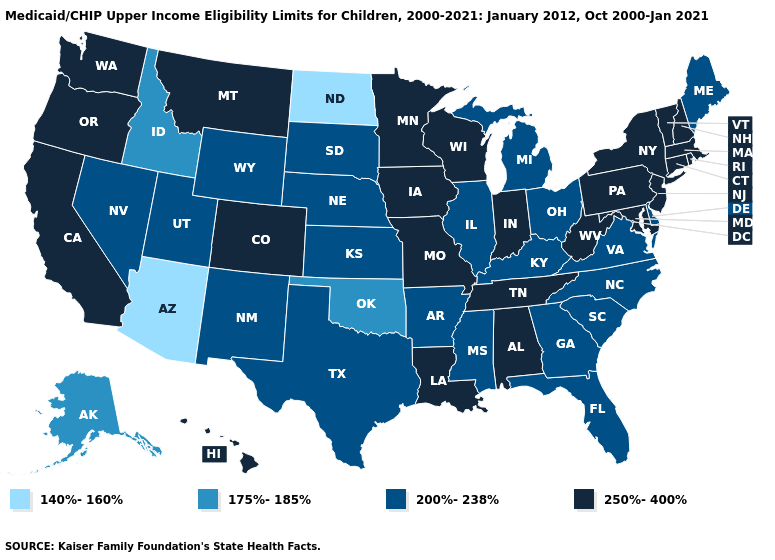Which states have the highest value in the USA?
Answer briefly. Alabama, California, Colorado, Connecticut, Hawaii, Indiana, Iowa, Louisiana, Maryland, Massachusetts, Minnesota, Missouri, Montana, New Hampshire, New Jersey, New York, Oregon, Pennsylvania, Rhode Island, Tennessee, Vermont, Washington, West Virginia, Wisconsin. What is the value of Wyoming?
Keep it brief. 200%-238%. Which states hav the highest value in the West?
Give a very brief answer. California, Colorado, Hawaii, Montana, Oregon, Washington. Name the states that have a value in the range 200%-238%?
Quick response, please. Arkansas, Delaware, Florida, Georgia, Illinois, Kansas, Kentucky, Maine, Michigan, Mississippi, Nebraska, Nevada, New Mexico, North Carolina, Ohio, South Carolina, South Dakota, Texas, Utah, Virginia, Wyoming. Which states have the lowest value in the MidWest?
Write a very short answer. North Dakota. What is the lowest value in the USA?
Write a very short answer. 140%-160%. Which states have the highest value in the USA?
Write a very short answer. Alabama, California, Colorado, Connecticut, Hawaii, Indiana, Iowa, Louisiana, Maryland, Massachusetts, Minnesota, Missouri, Montana, New Hampshire, New Jersey, New York, Oregon, Pennsylvania, Rhode Island, Tennessee, Vermont, Washington, West Virginia, Wisconsin. Name the states that have a value in the range 175%-185%?
Concise answer only. Alaska, Idaho, Oklahoma. Is the legend a continuous bar?
Give a very brief answer. No. Which states have the lowest value in the Northeast?
Keep it brief. Maine. What is the lowest value in the USA?
Answer briefly. 140%-160%. Name the states that have a value in the range 200%-238%?
Give a very brief answer. Arkansas, Delaware, Florida, Georgia, Illinois, Kansas, Kentucky, Maine, Michigan, Mississippi, Nebraska, Nevada, New Mexico, North Carolina, Ohio, South Carolina, South Dakota, Texas, Utah, Virginia, Wyoming. Does Alabama have the highest value in the South?
Quick response, please. Yes. What is the lowest value in the USA?
Be succinct. 140%-160%. Among the states that border Michigan , which have the highest value?
Short answer required. Indiana, Wisconsin. 